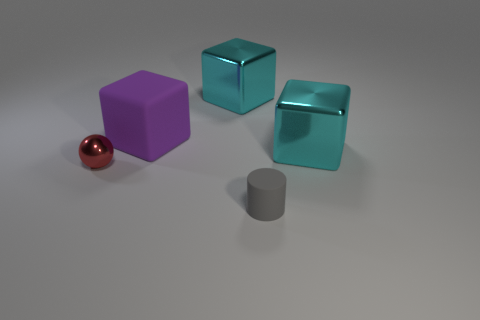Add 1 small purple rubber objects. How many objects exist? 6 Subtract all blocks. How many objects are left? 2 Add 4 blocks. How many blocks exist? 7 Subtract 0 cyan cylinders. How many objects are left? 5 Subtract all brown metallic blocks. Subtract all metallic cubes. How many objects are left? 3 Add 1 large purple rubber cubes. How many large purple rubber cubes are left? 2 